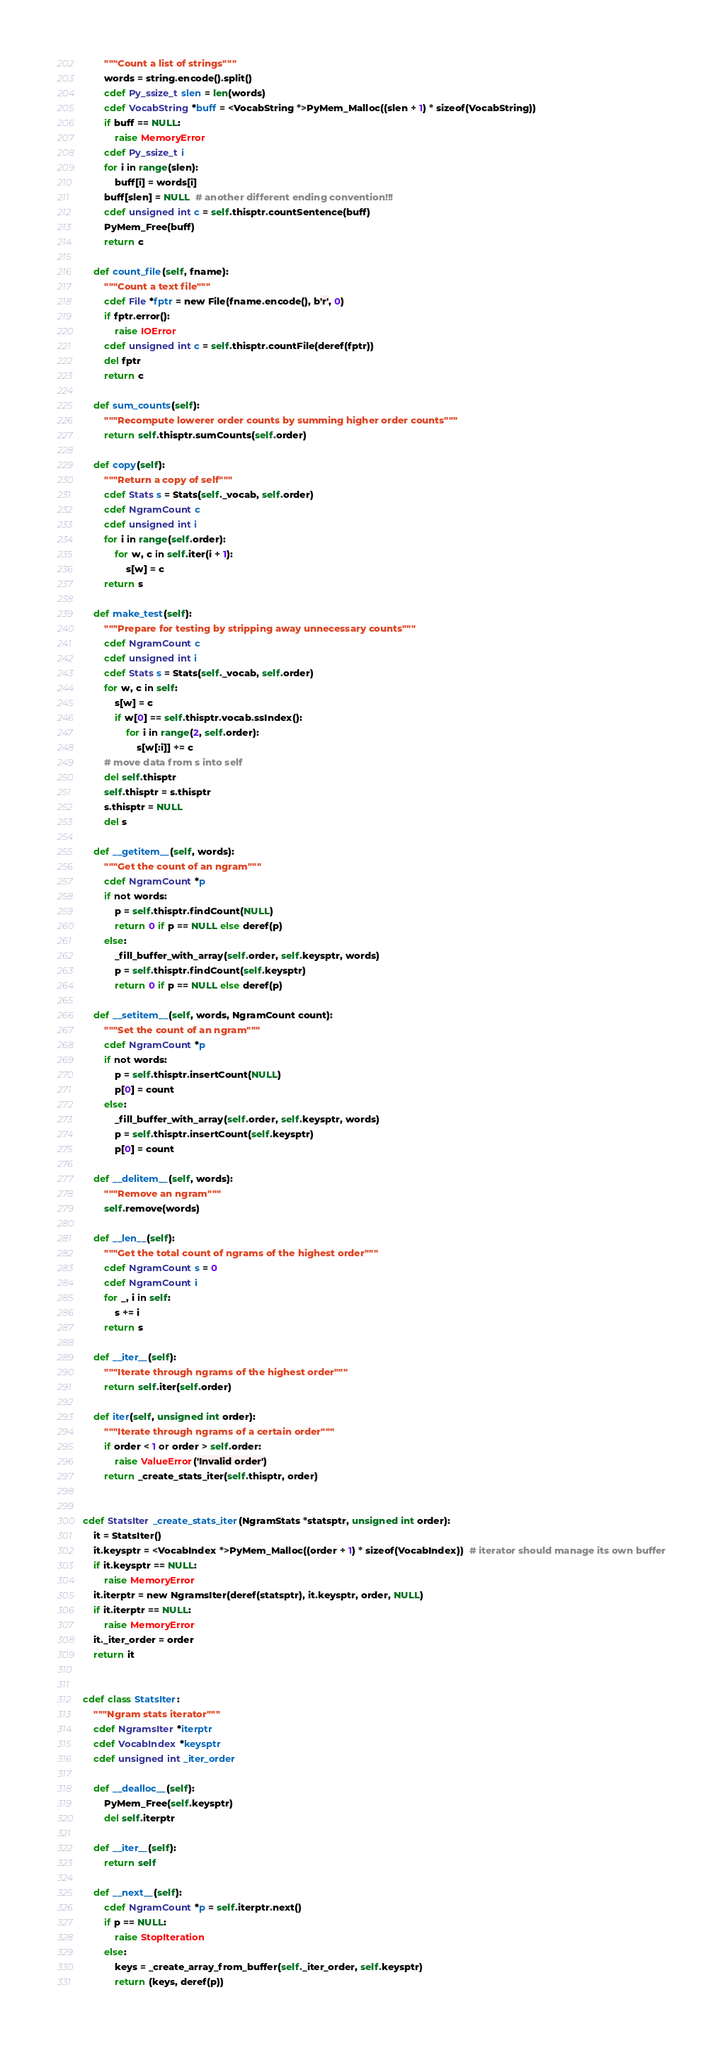Convert code to text. <code><loc_0><loc_0><loc_500><loc_500><_Cython_>        """Count a list of strings"""
        words = string.encode().split()
        cdef Py_ssize_t slen = len(words)
        cdef VocabString *buff = <VocabString *>PyMem_Malloc((slen + 1) * sizeof(VocabString))
        if buff == NULL:
            raise MemoryError
        cdef Py_ssize_t i
        for i in range(slen):
            buff[i] = words[i]
        buff[slen] = NULL  # another different ending convention!!!
        cdef unsigned int c = self.thisptr.countSentence(buff)
        PyMem_Free(buff)
        return c

    def count_file(self, fname):
        """Count a text file"""
        cdef File *fptr = new File(fname.encode(), b'r', 0)
        if fptr.error():
            raise IOError
        cdef unsigned int c = self.thisptr.countFile(deref(fptr))
        del fptr
        return c

    def sum_counts(self):
        """Recompute lowerer order counts by summing higher order counts"""
        return self.thisptr.sumCounts(self.order)

    def copy(self):
        """Return a copy of self"""
        cdef Stats s = Stats(self._vocab, self.order)
        cdef NgramCount c
        cdef unsigned int i
        for i in range(self.order):
            for w, c in self.iter(i + 1):
                s[w] = c
        return s

    def make_test(self):
        """Prepare for testing by stripping away unnecessary counts"""
        cdef NgramCount c
        cdef unsigned int i
        cdef Stats s = Stats(self._vocab, self.order)
        for w, c in self:
            s[w] = c
            if w[0] == self.thisptr.vocab.ssIndex():
                for i in range(2, self.order):
                    s[w[:i]] += c
        # move data from s into self
        del self.thisptr
        self.thisptr = s.thisptr
        s.thisptr = NULL
        del s

    def __getitem__(self, words):
        """Get the count of an ngram"""
        cdef NgramCount *p
        if not words:
            p = self.thisptr.findCount(NULL)
            return 0 if p == NULL else deref(p)
        else:
            _fill_buffer_with_array(self.order, self.keysptr, words)
            p = self.thisptr.findCount(self.keysptr)
            return 0 if p == NULL else deref(p)

    def __setitem__(self, words, NgramCount count):
        """Set the count of an ngram"""
        cdef NgramCount *p
        if not words:
            p = self.thisptr.insertCount(NULL)
            p[0] = count
        else:
            _fill_buffer_with_array(self.order, self.keysptr, words)
            p = self.thisptr.insertCount(self.keysptr)
            p[0] = count

    def __delitem__(self, words):
        """Remove an ngram"""
        self.remove(words)

    def __len__(self):
        """Get the total count of ngrams of the highest order"""
        cdef NgramCount s = 0
        cdef NgramCount i
        for _, i in self:
            s += i
        return s

    def __iter__(self):
        """Iterate through ngrams of the highest order"""
        return self.iter(self.order)

    def iter(self, unsigned int order):
        """Iterate through ngrams of a certain order"""
        if order < 1 or order > self.order:
            raise ValueError('Invalid order')
        return _create_stats_iter(self.thisptr, order)


cdef StatsIter _create_stats_iter(NgramStats *statsptr, unsigned int order):
    it = StatsIter()
    it.keysptr = <VocabIndex *>PyMem_Malloc((order + 1) * sizeof(VocabIndex))  # iterator should manage its own buffer
    if it.keysptr == NULL:
        raise MemoryError
    it.iterptr = new NgramsIter(deref(statsptr), it.keysptr, order, NULL)
    if it.iterptr == NULL:
        raise MemoryError
    it._iter_order = order
    return it


cdef class StatsIter:
    """Ngram stats iterator"""
    cdef NgramsIter *iterptr
    cdef VocabIndex *keysptr
    cdef unsigned int _iter_order

    def __dealloc__(self):
        PyMem_Free(self.keysptr)
        del self.iterptr

    def __iter__(self):
        return self

    def __next__(self):
        cdef NgramCount *p = self.iterptr.next()
        if p == NULL:
            raise StopIteration
        else:
            keys = _create_array_from_buffer(self._iter_order, self.keysptr)
            return (keys, deref(p))
</code> 